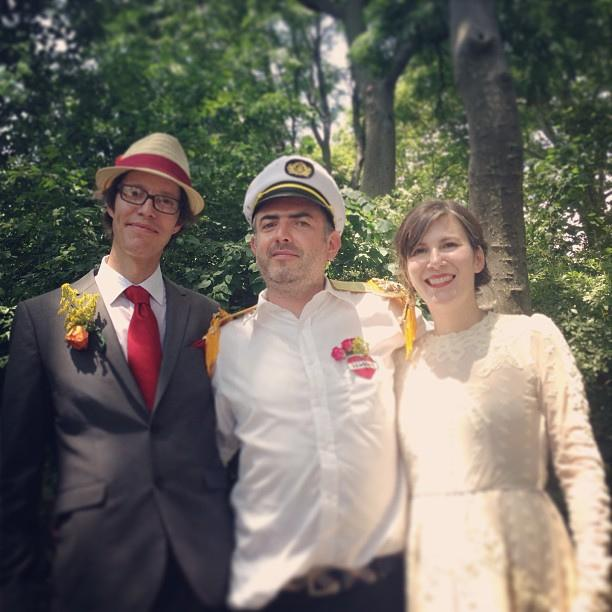What type of hat does the man in white have on?

Choices:
A) captains
B) skating
C) athletic
D) fisherman captains 